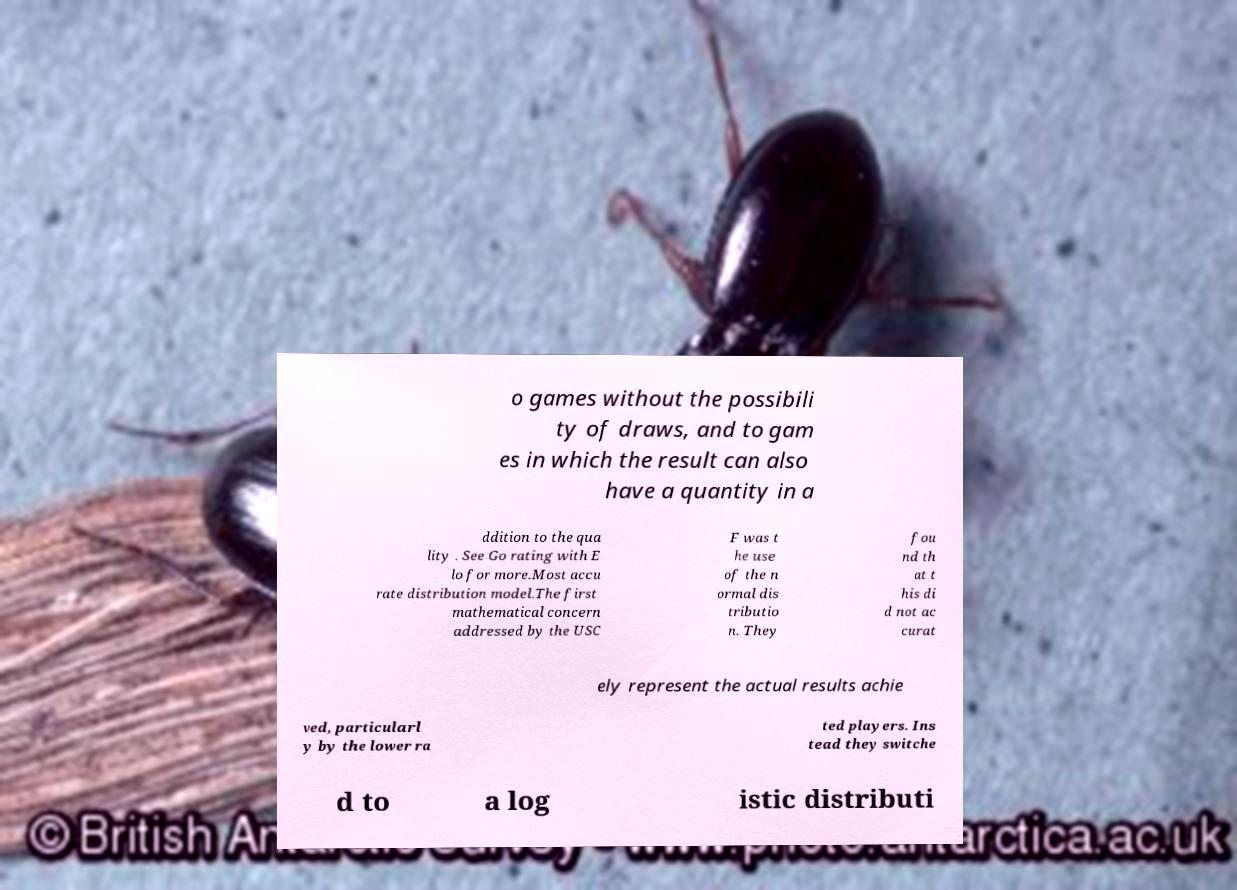There's text embedded in this image that I need extracted. Can you transcribe it verbatim? o games without the possibili ty of draws, and to gam es in which the result can also have a quantity in a ddition to the qua lity . See Go rating with E lo for more.Most accu rate distribution model.The first mathematical concern addressed by the USC F was t he use of the n ormal dis tributio n. They fou nd th at t his di d not ac curat ely represent the actual results achie ved, particularl y by the lower ra ted players. Ins tead they switche d to a log istic distributi 